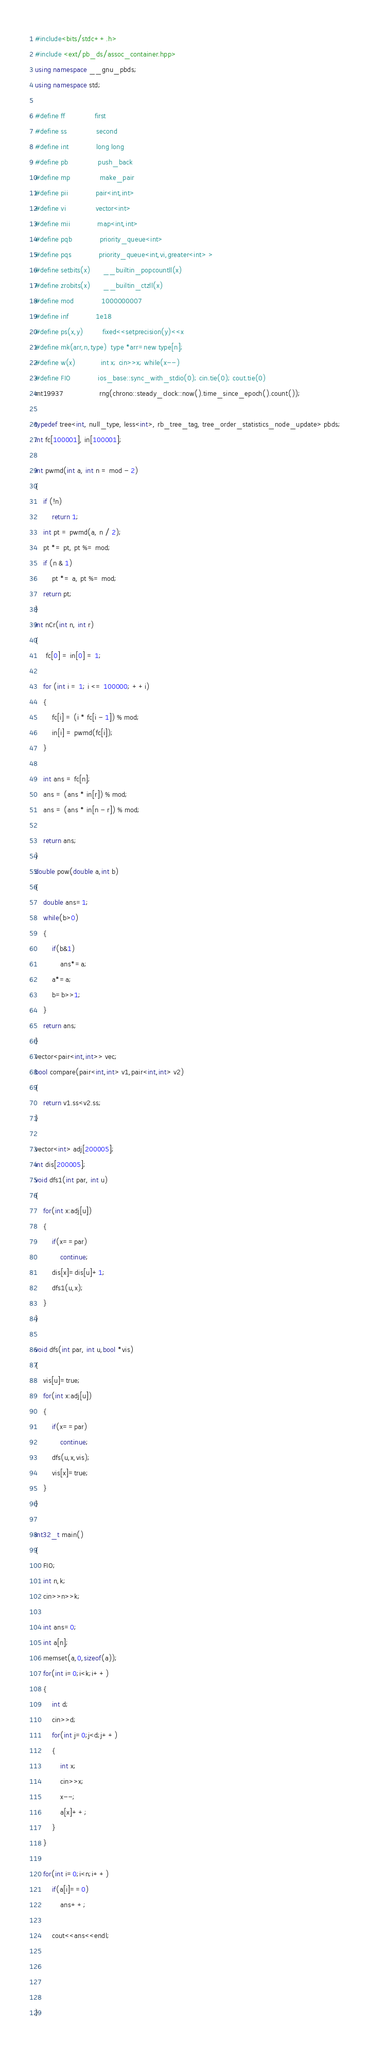Convert code to text. <code><loc_0><loc_0><loc_500><loc_500><_C++_>#include<bits/stdc++.h>
#include <ext/pb_ds/assoc_container.hpp> 
using namespace __gnu_pbds; 
using namespace std;

#define ff              first
#define ss              second
#define int             long long
#define pb              push_back
#define mp              make_pair
#define pii             pair<int,int>
#define vi              vector<int>
#define mii             map<int,int>
#define pqb             priority_queue<int>
#define pqs             priority_queue<int,vi,greater<int> >
#define setbits(x)      __builtin_popcountll(x)
#define zrobits(x)      __builtin_ctzll(x)
#define mod             1000000007
#define inf             1e18
#define ps(x,y)         fixed<<setprecision(y)<<x
#define mk(arr,n,type)  type *arr=new type[n];
#define w(x)            int x; cin>>x; while(x--)
#define FIO             ios_base::sync_with_stdio(0); cin.tie(0); cout.tie(0)
mt19937                 rng(chrono::steady_clock::now().time_since_epoch().count());

typedef tree<int, null_type, less<int>, rb_tree_tag, tree_order_statistics_node_update> pbds;
int fc[100001], in[100001];

int pwmd(int a, int n = mod - 2)
{
	if (!n)
		return 1;
	int pt = pwmd(a, n / 2);
	pt *= pt, pt %= mod;
	if (n & 1)
		pt *= a, pt %= mod;
	return pt;
}
int nCr(int n, int r)
{
     fc[0] = in[0] = 1;

	for (int i = 1; i <= 100000; ++i)
	{
		fc[i] = (i * fc[i - 1]) % mod;
		in[i] = pwmd(fc[i]);
	}

	int ans = fc[n];
	ans = (ans * in[r]) % mod;
	ans = (ans * in[n - r]) % mod;

	return ans;
}
double pow(double a,int b)
{
	double ans=1;
	while(b>0)
	{
		if(b&1)
			ans*=a;
		a*=a;
		b=b>>1;
	}
	return ans;
}
vector<pair<int,int>> vec;
bool compare(pair<int,int> v1,pair<int,int> v2)
{
	return v1.ss<v2.ss;
}

vector<int> adj[200005];
int dis[200005];
void dfs1(int par, int u)
{
	for(int x:adj[u])
	{
		if(x==par)
			continue;
		dis[x]=dis[u]+1;
		dfs1(u,x);
	}
}

void dfs(int par, int u,bool *vis)
{
	vis[u]=true;
	for(int x:adj[u])
	{
		if(x==par)
			continue;
		dfs(u,x,vis);
		vis[x]=true;
	}
}

int32_t main()
{       
    FIO;
    int n,k;
    cin>>n>>k;

    int ans=0;
    int a[n];
    memset(a,0,sizeof(a));
    for(int i=0;i<k;i++)
    {
    	int d;
    	cin>>d;
    	for(int j=0;j<d;j++)
    	{
    		int x;
    		cin>>x;
    		x--;
    		a[x]++;
    	}
    }

    for(int i=0;i<n;i++)
    	if(a[i]==0)
    		ans++;

    	cout<<ans<<endl;
   
    


}</code> 